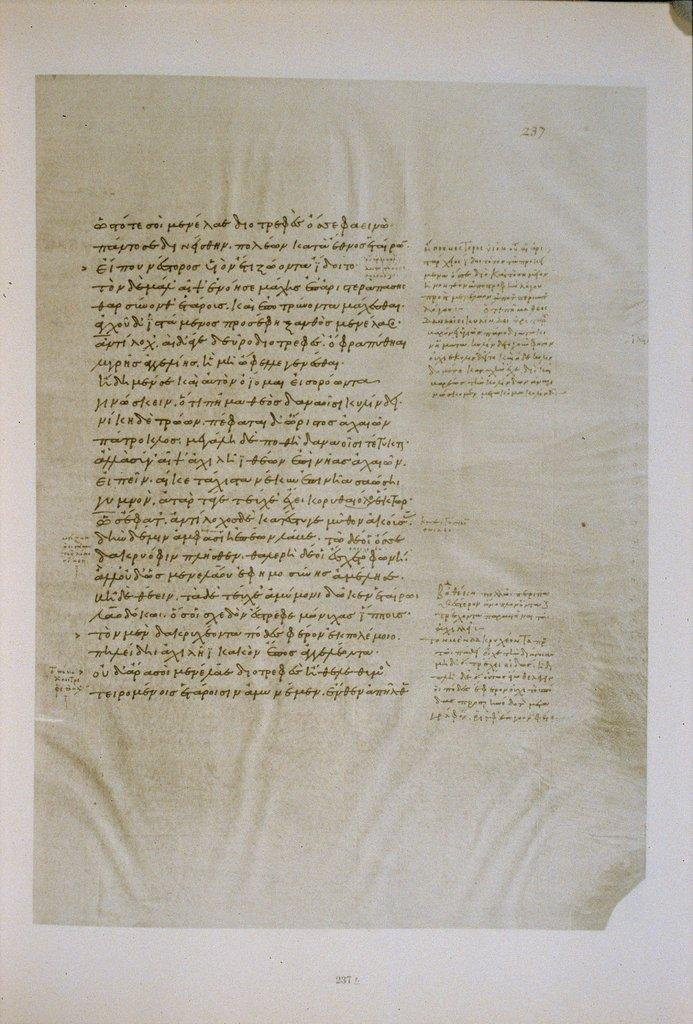<image>
Write a terse but informative summary of the picture. A page of text that is not in the English language. 